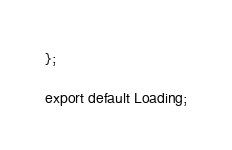Convert code to text. <code><loc_0><loc_0><loc_500><loc_500><_JavaScript_>};

export default Loading;
</code> 